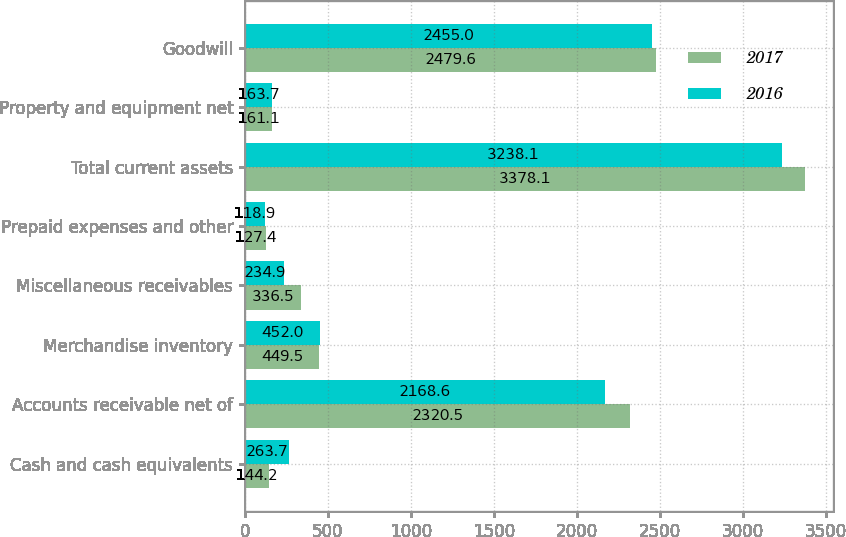Convert chart. <chart><loc_0><loc_0><loc_500><loc_500><stacked_bar_chart><ecel><fcel>Cash and cash equivalents<fcel>Accounts receivable net of<fcel>Merchandise inventory<fcel>Miscellaneous receivables<fcel>Prepaid expenses and other<fcel>Total current assets<fcel>Property and equipment net<fcel>Goodwill<nl><fcel>2017<fcel>144.2<fcel>2320.5<fcel>449.5<fcel>336.5<fcel>127.4<fcel>3378.1<fcel>161.1<fcel>2479.6<nl><fcel>2016<fcel>263.7<fcel>2168.6<fcel>452<fcel>234.9<fcel>118.9<fcel>3238.1<fcel>163.7<fcel>2455<nl></chart> 